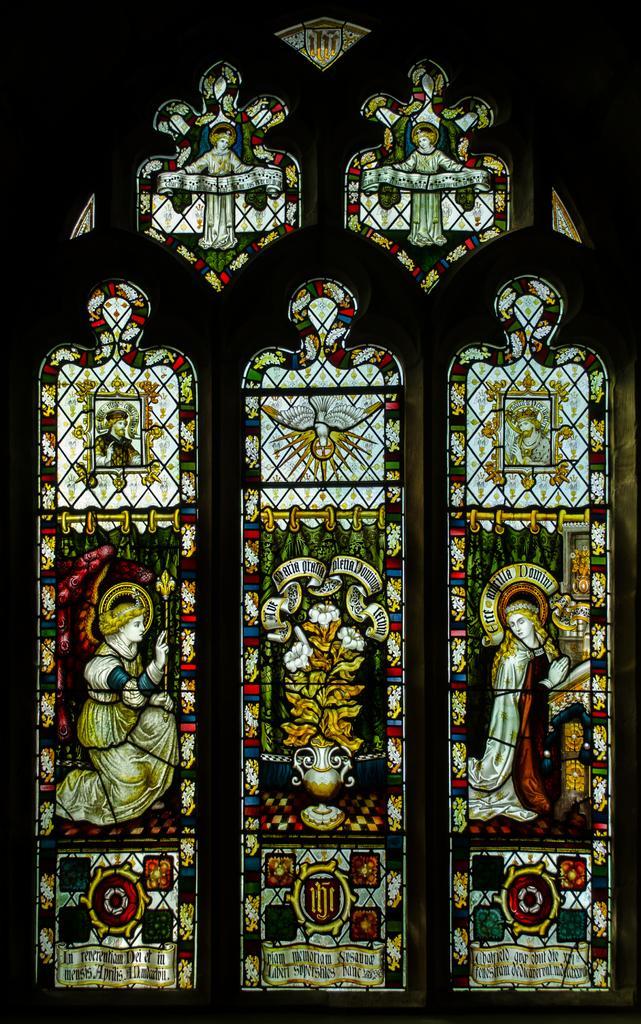Please provide a concise description of this image. In the image there is a window with designs on it on the wall. 